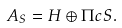Convert formula to latex. <formula><loc_0><loc_0><loc_500><loc_500>A _ { S } = H \oplus \Pi c S .</formula> 